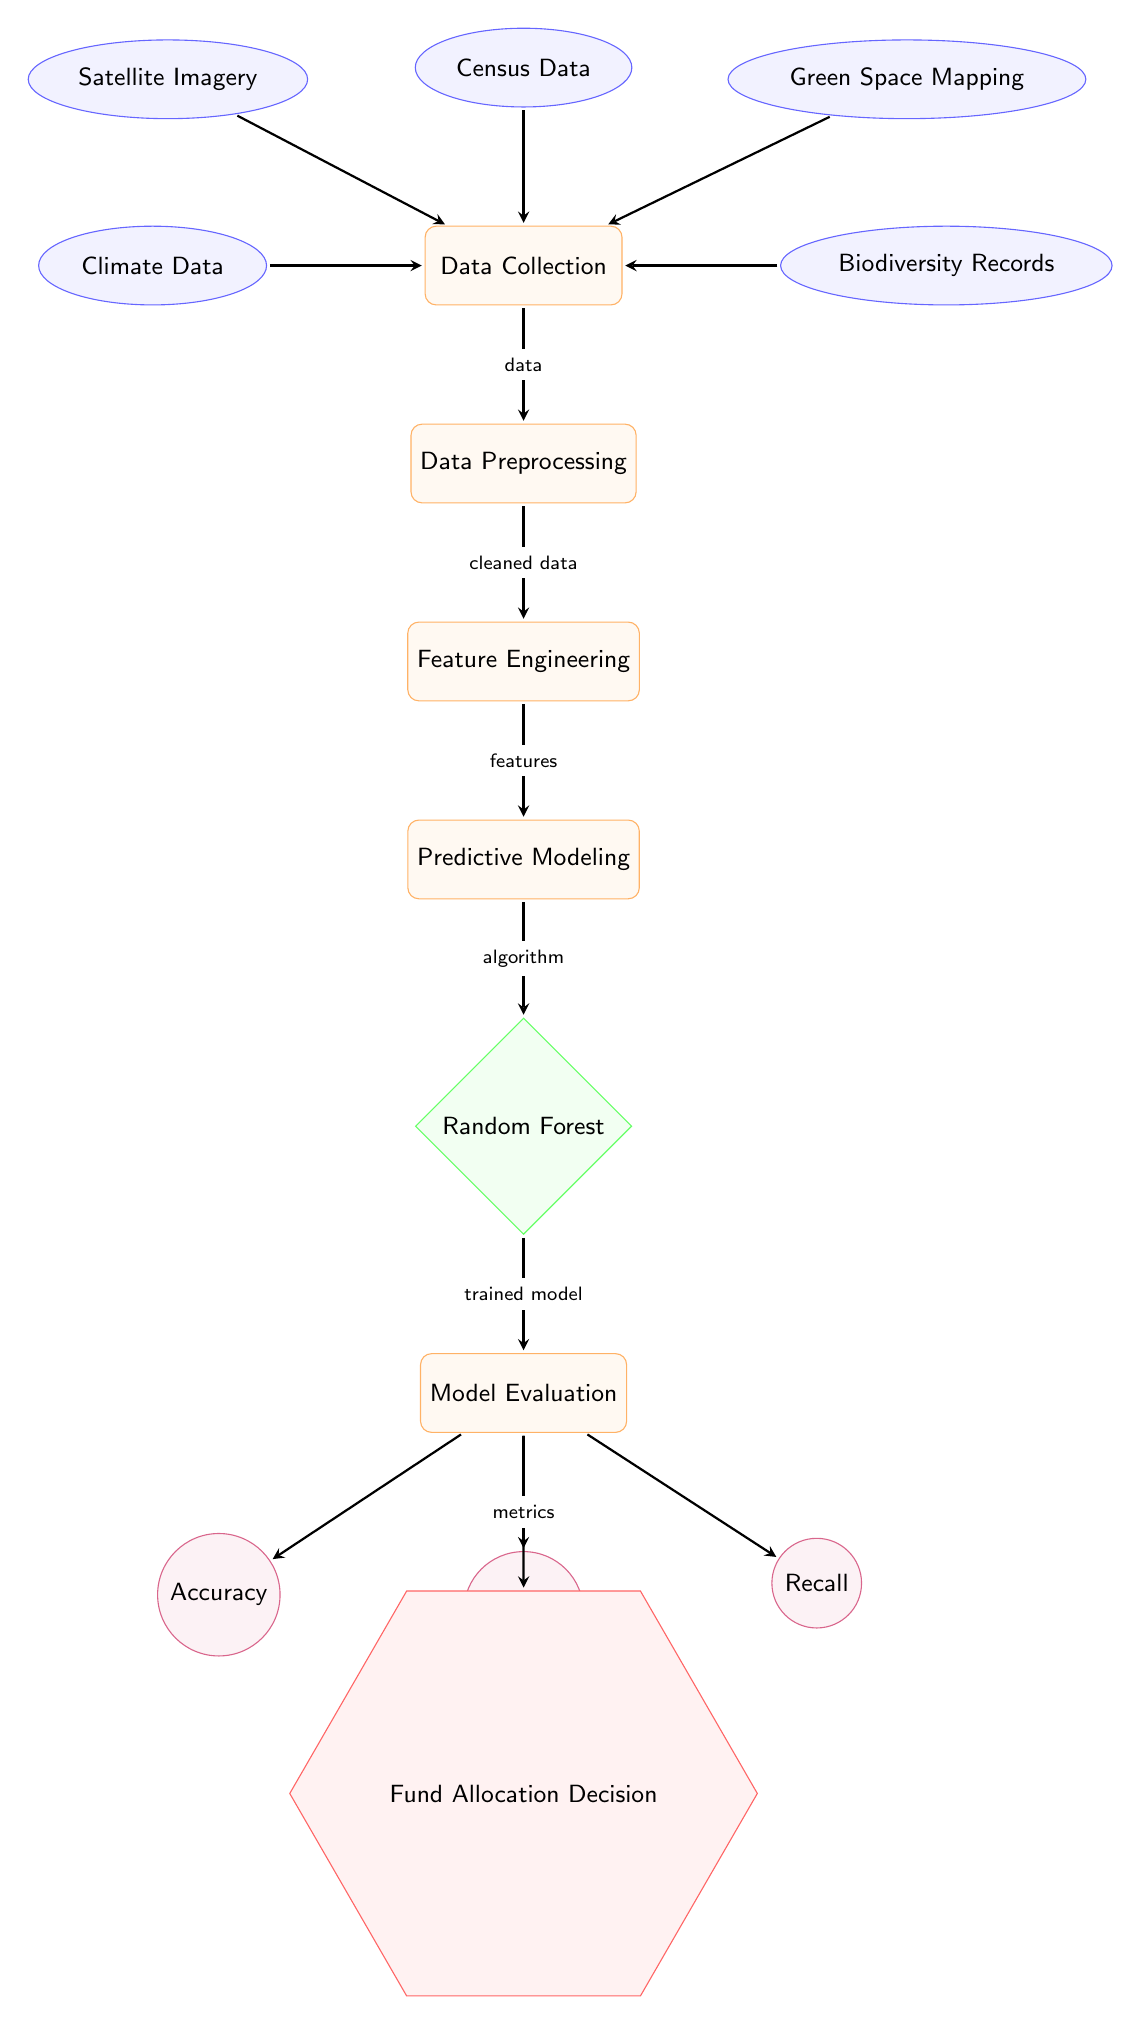What are the input data sources for the predictive model? The input data sources include satellite imagery, census data, green space mapping, climate data, and biodiversity records, all of which are connected to the data collection node in the diagram.
Answer: Satellite Imagery, Census Data, Green Space Mapping, Climate Data, Biodiversity Records How many evaluation metrics are shown in the diagram? The diagram displays three evaluation metrics: accuracy, precision, and recall, which are depicted below the model evaluation process in the diagram.
Answer: Three What is the final decision node labeled as? The final decision node in the diagram is labeled as "Fund Allocation Decision," located below the evaluation metrics, indicating the outcome of the entire predictive modeling process.
Answer: Fund Allocation Decision Which process comes directly after data preprocessing? The process that follows data preprocessing in the diagram is feature engineering, connected by an arrow indicating the flow from preprocessing to feature engineering.
Answer: Feature Engineering How does the model evaluation relate to the predictive model? The model evaluation process directly follows predictive modeling, as indicated by the arrow connecting the modeling node to the evaluation node, showing that model evaluation is based on the results of predictive modeling.
Answer: Directly follows What type of model is being used in this predictive modeling process? The type of model identified in the diagram for the predictive modeling process is a Random Forest model, which is represented by the diamond-shaped node labeled as such in the diagram.
Answer: Random Forest What do the arrows in the diagram represent? The arrows in the diagram represent the flow of processes and data, indicating the direction of data and the sequence of actions from data collection through to the final decision.
Answer: Flow of processes and data Which step involves transforming raw data into usable features? The step that involves transforming raw data into usable features is feature engineering, which takes place after data preprocessing and before predictive modeling according to the diagram.
Answer: Feature Engineering 